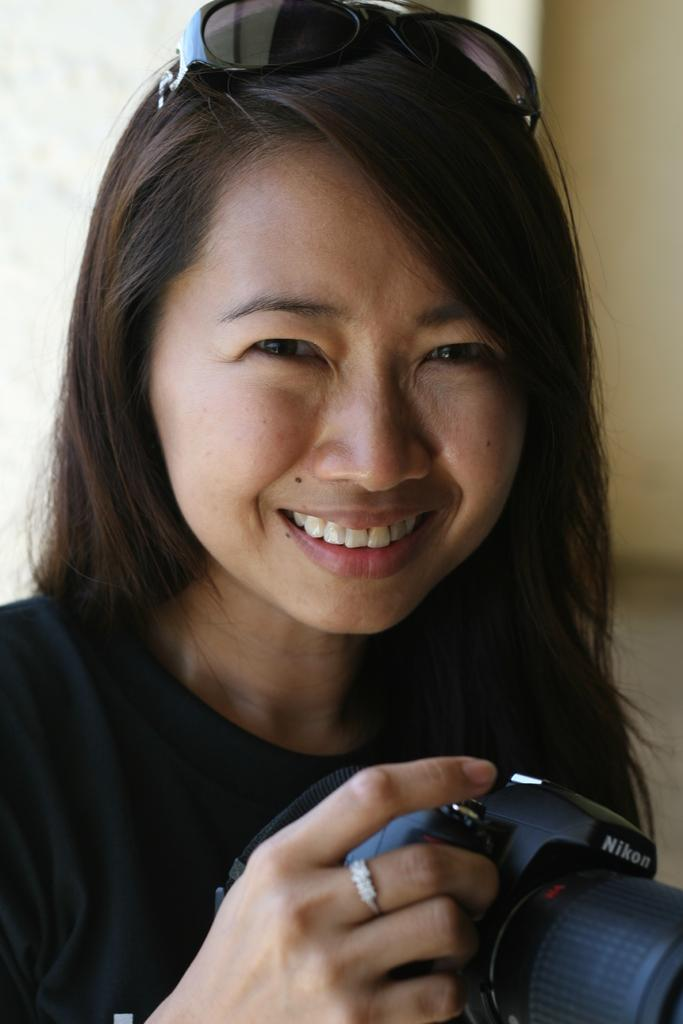Who is present in the image? There is a woman in the image. What is the woman doing in the image? The woman is smiling in the image. What object is the woman holding in her hands? The woman is holding a camera in her hands. What can be seen in the background of the image? There is a wall in the background of the image. What type of metal can be seen in the hole in the wall in the image? There is no hole or metal present in the image; it only features a woman, her smile, and a camera. 